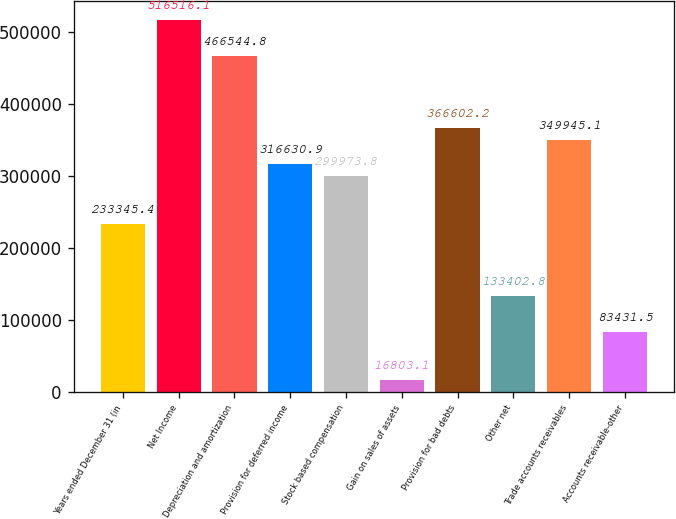Convert chart to OTSL. <chart><loc_0><loc_0><loc_500><loc_500><bar_chart><fcel>Years ended December 31 (in<fcel>Net Income<fcel>Depreciation and amortization<fcel>Provision for deferred income<fcel>Stock based compensation<fcel>Gain on sales of assets<fcel>Provision for bad debts<fcel>Other net<fcel>Trade accounts receivables<fcel>Accounts receivable-other<nl><fcel>233345<fcel>516516<fcel>466545<fcel>316631<fcel>299974<fcel>16803.1<fcel>366602<fcel>133403<fcel>349945<fcel>83431.5<nl></chart> 